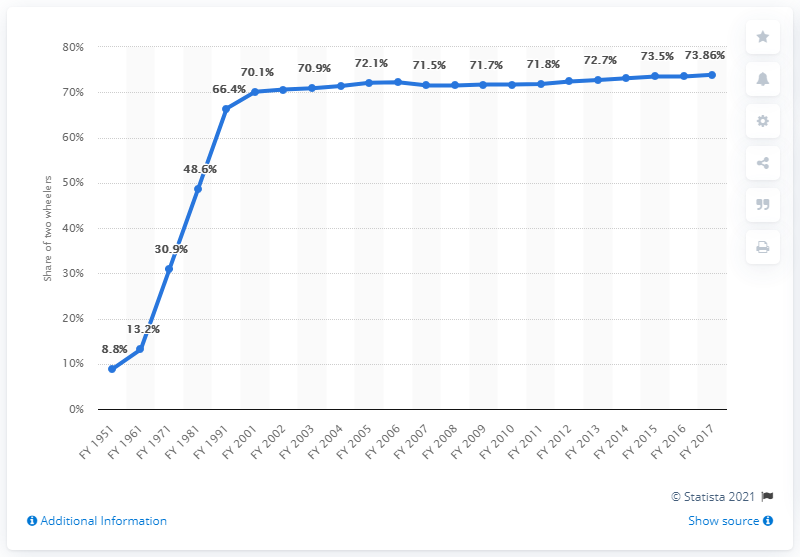Highlight a few significant elements in this photo. The rate of growth in the number of data points began to decrease in FY 2001. In the fiscal year 2017, approximately 73.86% of India's total vehicle fleet consisted of two-wheelers. The maximum value of the chart is 73.86. 